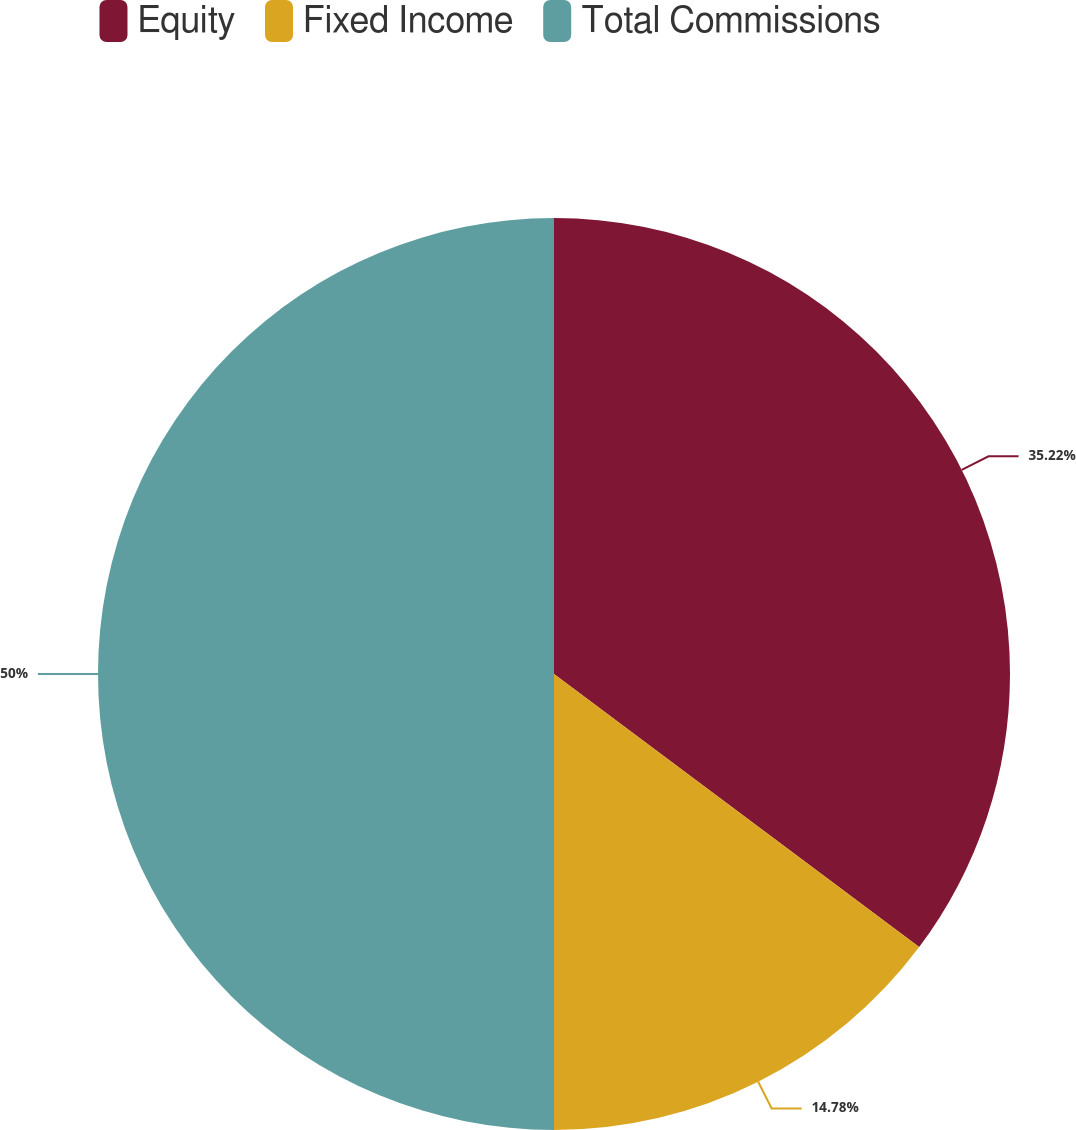Convert chart to OTSL. <chart><loc_0><loc_0><loc_500><loc_500><pie_chart><fcel>Equity<fcel>Fixed Income<fcel>Total Commissions<nl><fcel>35.22%<fcel>14.78%<fcel>50.0%<nl></chart> 